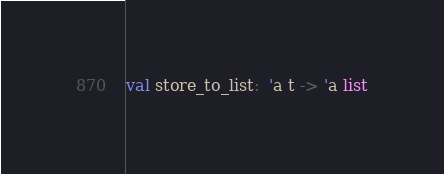Convert code to text. <code><loc_0><loc_0><loc_500><loc_500><_OCaml_>val store_to_list:  'a t -> 'a list

</code> 